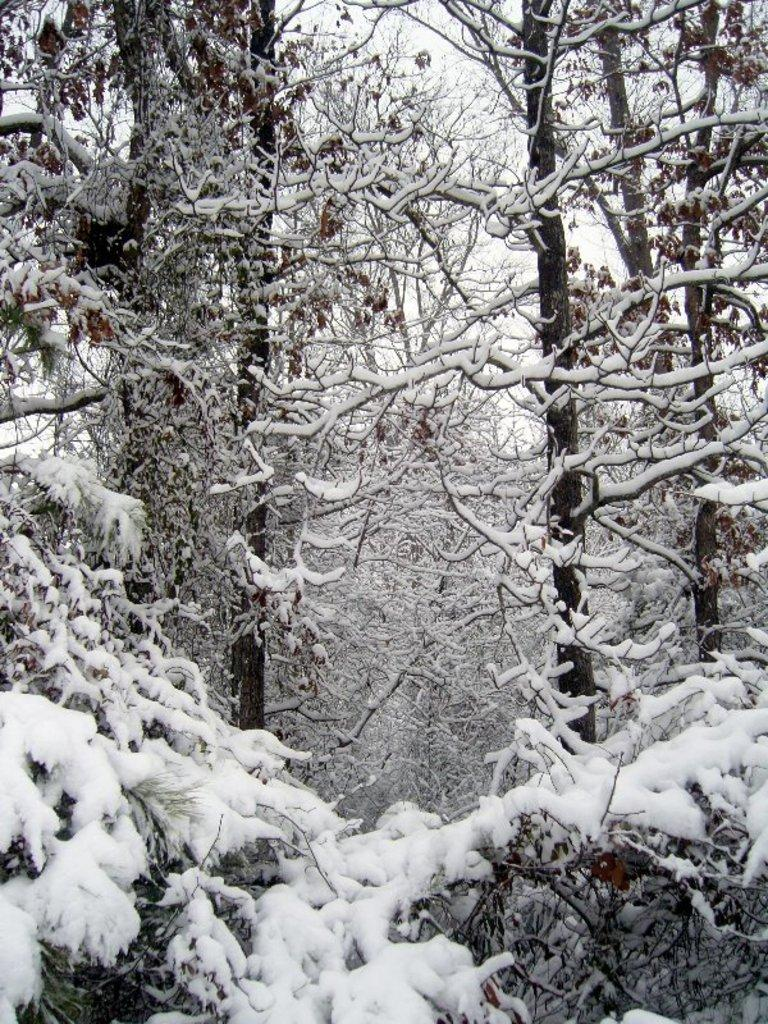What is the condition of the trees in the image? The trees in the image are covered with snow. What can be seen in the background of the image? There is a sky visible in the background of the image. How many beds are visible in the image? There are no beds present in the image; it features trees covered with snow and a sky in the background. 